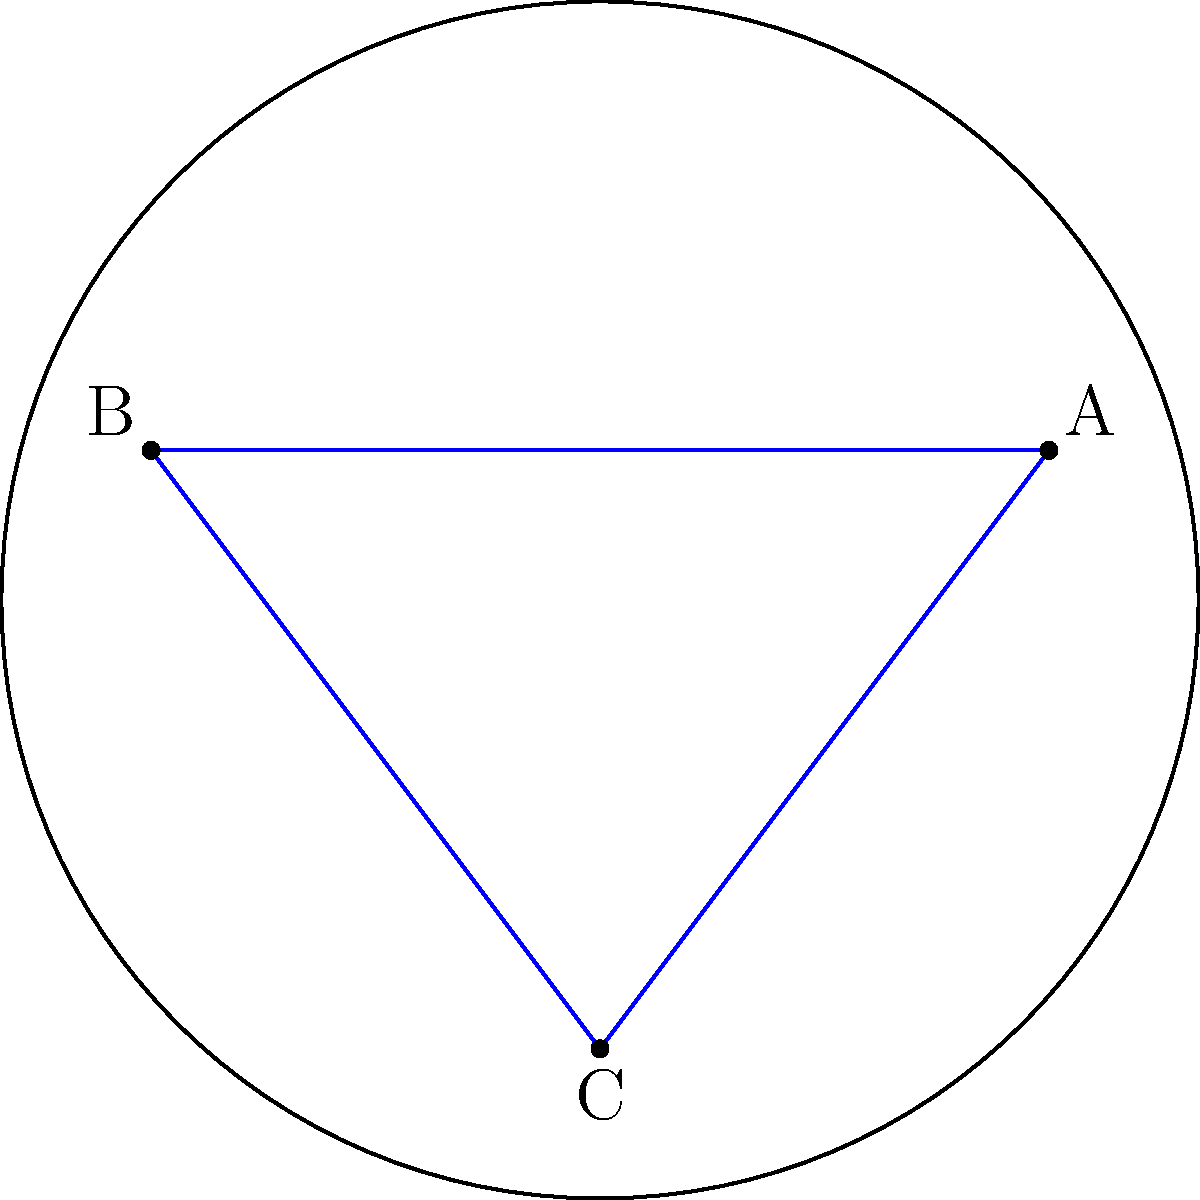A recycling truck needs to travel from point A to point B on a spherical surface. If the truck follows the shortest path between these points, which geometric figure would best represent its route? How does this differ from the Euclidean shortest path, and why is this important for optimizing recycling routes? To answer this question, let's consider the following steps:

1. In Euclidean geometry (flat surface), the shortest path between two points is a straight line. This would be represented by the blue line segment AB in the diagram.

2. However, on a curved surface like a sphere (which is an example of non-Euclidean geometry), the shortest path between two points is not a straight line, but rather a great circle arc.

3. A great circle is the intersection of a sphere with a plane that passes through the center of the sphere. The arc of a great circle between two points represents the shortest path on the sphere's surface.

4. In the diagram, the red dashed line represents the great circle arc between points A and B. This arc is shorter than the straight line segment AB when measured along the surface.

5. This concept is crucial for optimizing recycling routes because:
   a) Earth is approximately spherical, so long-distance routes are affected by this principle.
   b) Using great circle routes can significantly reduce travel distances, saving fuel and time.
   c) More efficient routes lead to reduced emissions and lower operational costs for recycling programs.

6. The difference between the Euclidean path and the non-Euclidean path increases as the distance between points increases relative to the sphere's size.

7. In practice, recycling trucks may not always follow exact great circle routes due to road networks and local geography, but understanding this principle can inform overall route planning and optimization strategies.
Answer: Great circle arc 